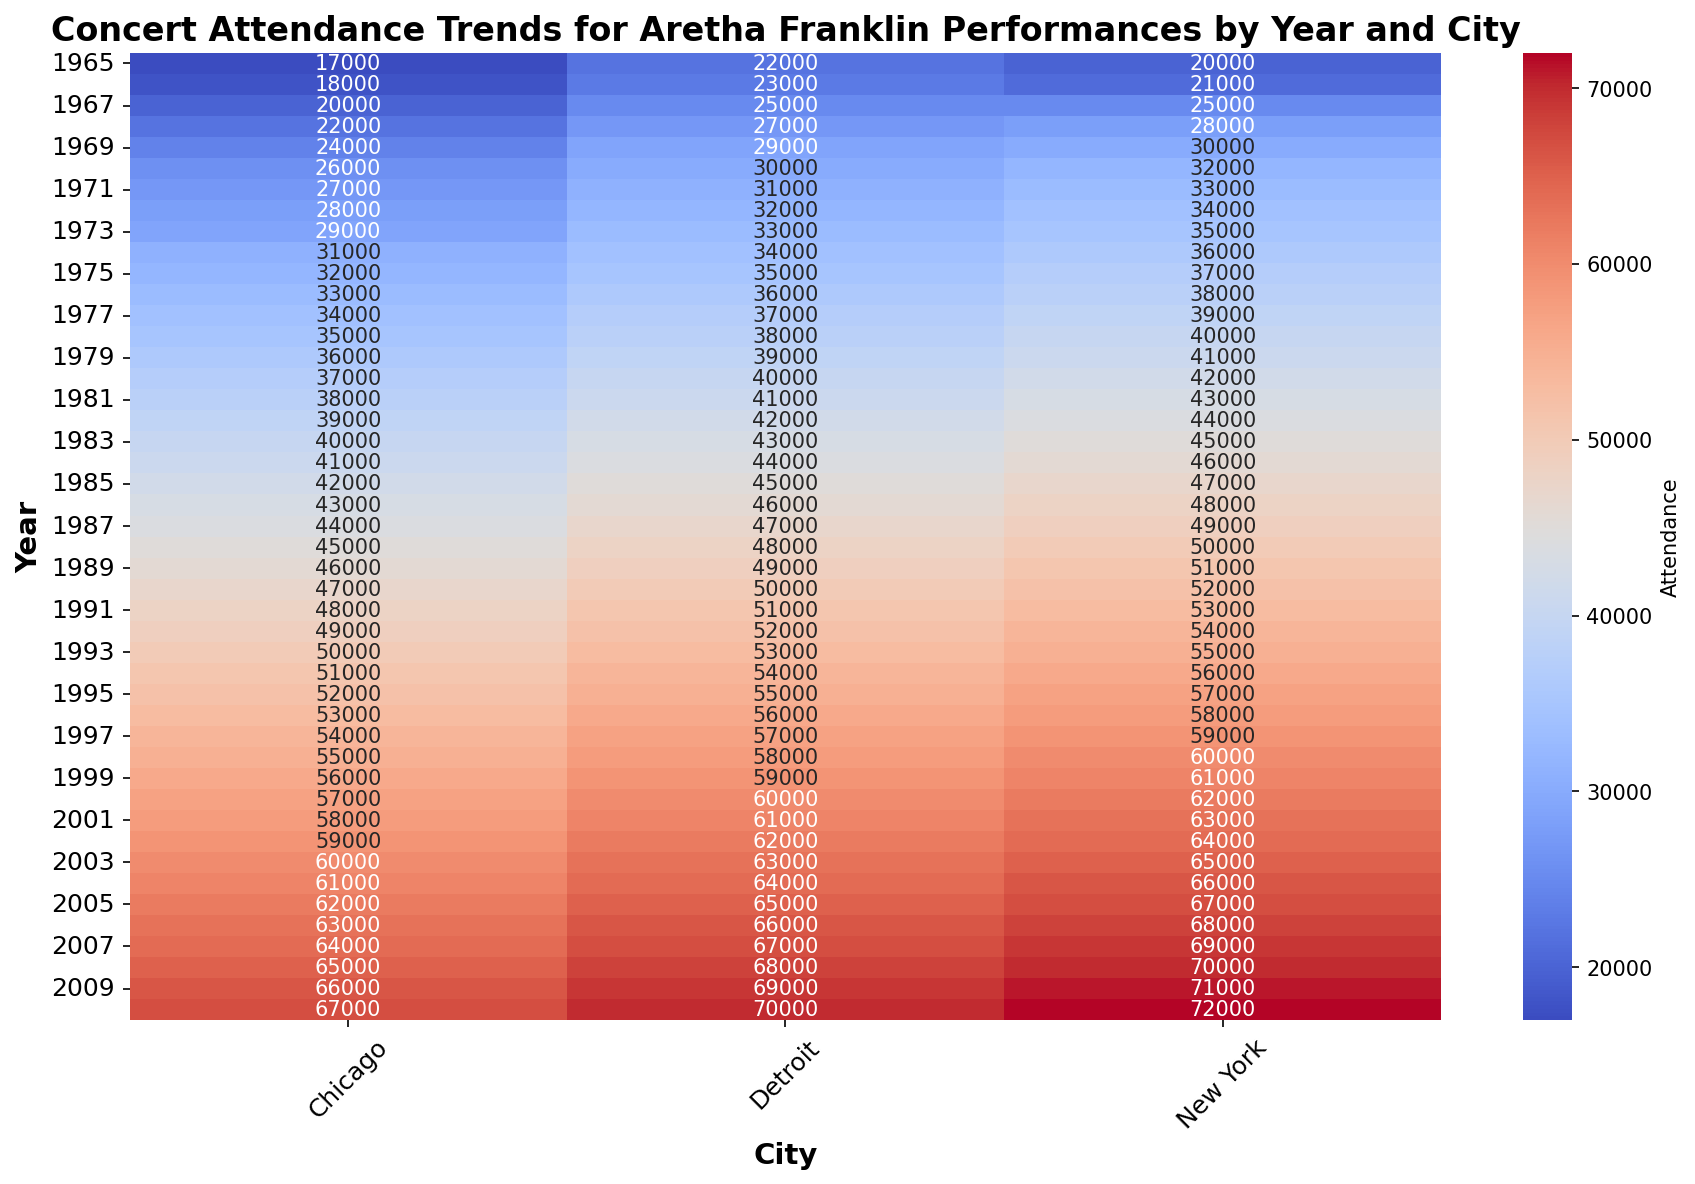Which city had the highest concert attendance in 1987? Look at the attendance values for all cities in 1987. New York has the highest value at 49,000.
Answer: New York What is the difference in concert attendance between Detroit and Chicago in 1975? Find the attendance for Detroit and Chicago in 1975 and subtract the Chicago value from the Detroit value. The values are 35,000 for Detroit and 32,000 for Chicago, so the difference is 35,000 - 32,000 = 3,000.
Answer: 3,000 Which year had the highest overall attendance across all cities? Sum the attendance values for each year across all cities, and identify the year with the highest total. In 2010, the total attendance is highest with New York at 72,000, Chicago at 67,000, and Detroit at 70,000 summing to 209,000.
Answer: 2010 What is the average concert attendance in Chicago between 1965 and 1975? Sum the attendance values for Chicago from 1965 to 1975, and divide by the number of years. The sum is 17,000 + 18,000 + 20,000 + 22,000 + 24,000 + 26,000 + 27,000 + 28,000 + 29,000 + 31,000 + 32,000 = 224,000. There are 11 years, so the average is 224,000 / 11 ≈ 20,364.
Answer: 20,364 In which city did concert attendance grow the fastest between 1965 and 2010? For each city, find the difference in attendance between 1965 and 2010. Compare these differences to determine the city with the largest increase. New York: 72,000 - 20,000 = 52,000, Chicago: 67,000 - 17,000 = 50,000, Detroit: 70,000 - 22,000 = 48,000. Therefore, New York grew the fastest.
Answer: New York What is the trend in concert attendance in New York over the years 1965 to 2010? Observe the color gradient for New York from 1965 to 2010. The colors change from lighter to darker red, indicating a consistent increase in attendance. The numbers support this observation, showing a steady increase from 20,000 to 72,000.
Answer: Increasing How did concert attendance in Detroit in 1985 compare to that in Chicago in 1995? Look at the attendance numbers for Detroit in 1985 and Chicago in 1995. Detroit in 1985 had an attendance of 45,000, and Chicago in 1995 had an attendance of 52,000. Chicago's attendance in 1995 was higher.
Answer: Chicago had higher What is the average annual increase in concert attendance in New York from 1988 to 1998? Calculate the difference in attendance between 1988 and 1998, then divide by the number of years. The attendance increases from 50,000 to 60,000, a difference of 10,000 over 10 years. The average annual increase is 10,000 / 10 = 1,000.
Answer: 1,000 Which year saw the largest increase in attendance in Detroit from the previous year? Examine the yearly attendance numbers and calculate the yearly differences for Detroit. The change from 1976 (36,000) to 1977 (37,000) gives the largest increase of 1,000.
Answer: 1977 